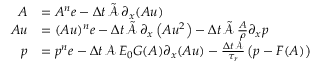<formula> <loc_0><loc_0><loc_500><loc_500>\begin{array} { r l } { A } & { = A ^ { n } e - \Delta t \, \tilde { \mathcal { A } } \, \partial _ { x } ( A u ) } \\ { A u } & { = ( A u ) ^ { n } e - \Delta t \, \tilde { \mathcal { A } } \, \partial _ { x } \left ( A u ^ { 2 } \right ) - \Delta t \, \tilde { \mathcal { A } } \, \frac { A } { \rho } \partial _ { x } p } \\ { p } & { = p ^ { n } e - \Delta t \, \mathcal { A } \, E _ { 0 } G ( A ) \partial _ { x } ( A u ) - \frac { \Delta t \, \mathcal { A } } { \tau _ { r } } \left ( p - F ( A ) \right ) } \end{array}</formula> 